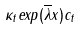Convert formula to latex. <formula><loc_0><loc_0><loc_500><loc_500>\kappa _ { t } e x p ( \overline { \lambda } x ) c _ { t }</formula> 